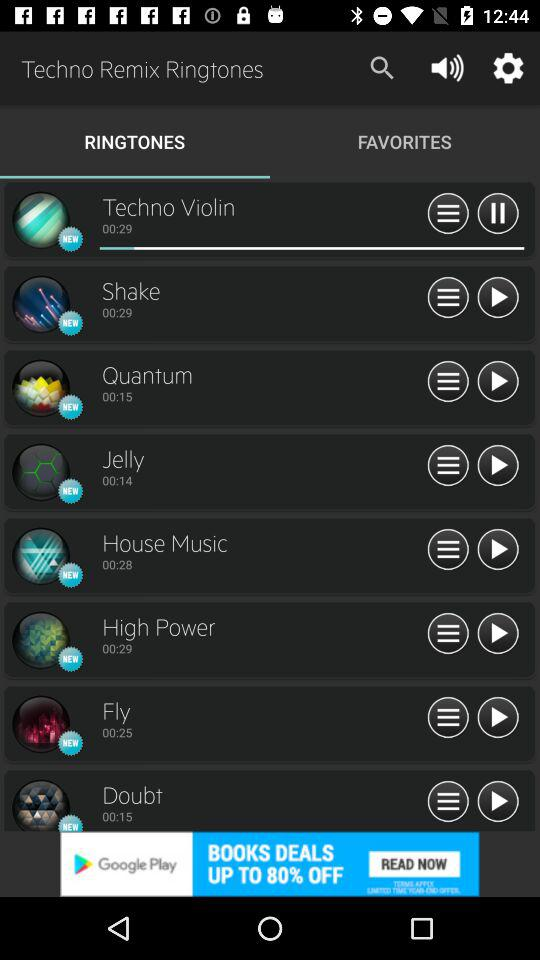What's the selected tab? The selected tab is "RINGTONES". 